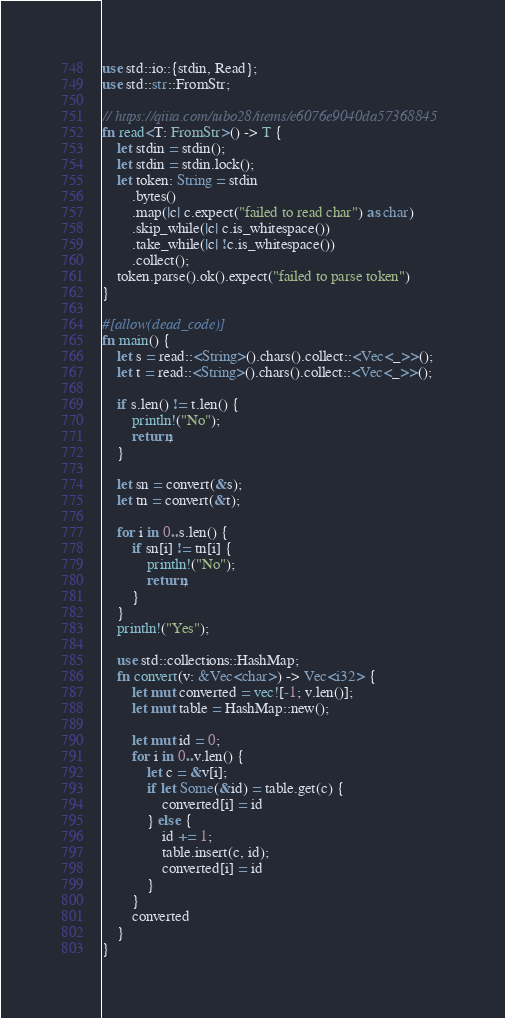<code> <loc_0><loc_0><loc_500><loc_500><_Rust_>use std::io::{stdin, Read};
use std::str::FromStr;

// https://qiita.com/tubo28/items/e6076e9040da57368845
fn read<T: FromStr>() -> T {
    let stdin = stdin();
    let stdin = stdin.lock();
    let token: String = stdin
        .bytes()
        .map(|c| c.expect("failed to read char") as char)
        .skip_while(|c| c.is_whitespace())
        .take_while(|c| !c.is_whitespace())
        .collect();
    token.parse().ok().expect("failed to parse token")
}

#[allow(dead_code)]
fn main() {
    let s = read::<String>().chars().collect::<Vec<_>>();
    let t = read::<String>().chars().collect::<Vec<_>>();

    if s.len() != t.len() {
        println!("No");
        return;
    }

    let sn = convert(&s);
    let tn = convert(&t);

    for i in 0..s.len() {
        if sn[i] != tn[i] {
            println!("No");
            return;
        }
    }
    println!("Yes");

    use std::collections::HashMap;
    fn convert(v: &Vec<char>) -> Vec<i32> {
        let mut converted = vec![-1; v.len()];
        let mut table = HashMap::new();

        let mut id = 0;
        for i in 0..v.len() {
            let c = &v[i];
            if let Some(&id) = table.get(c) {
                converted[i] = id
            } else {
                id += 1;
                table.insert(c, id);
                converted[i] = id
            }
        }
        converted
    }
}
</code> 